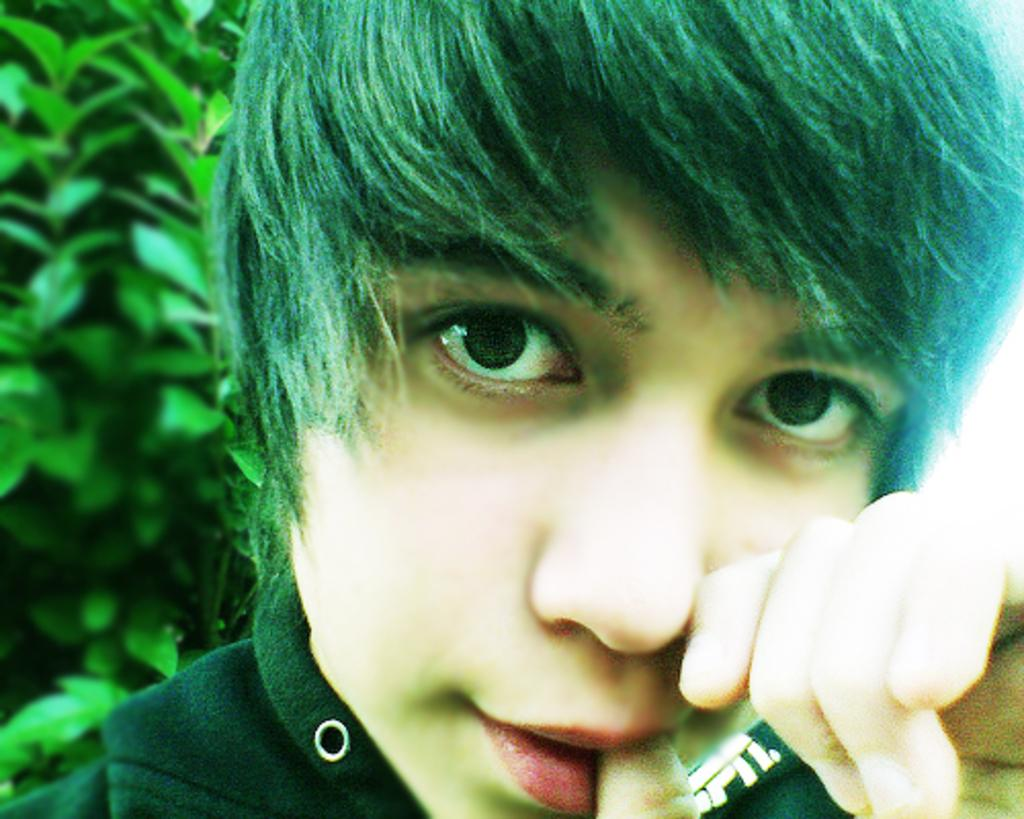Who is the main subject in the image? There is a child in the image. What is the child wearing? The child is wearing black clothes. What type of plant can be seen in the image? There is a green color plant in the image. How many balloons is the child holding in the image? There are no balloons present in the image. What type of coach is the child using to play in the image? There is no coach present in the image, and the child is not shown playing. 